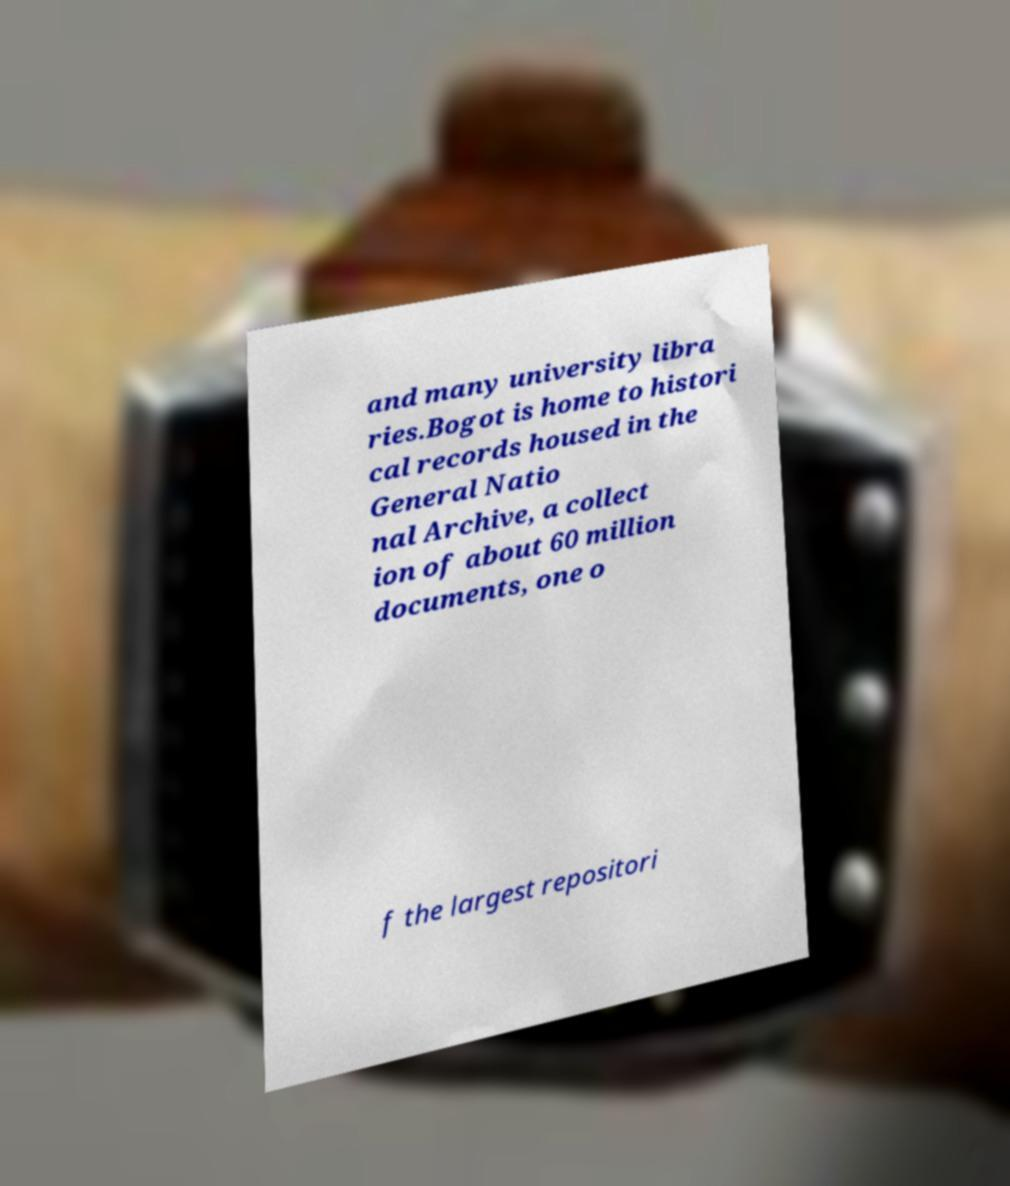Can you accurately transcribe the text from the provided image for me? and many university libra ries.Bogot is home to histori cal records housed in the General Natio nal Archive, a collect ion of about 60 million documents, one o f the largest repositori 